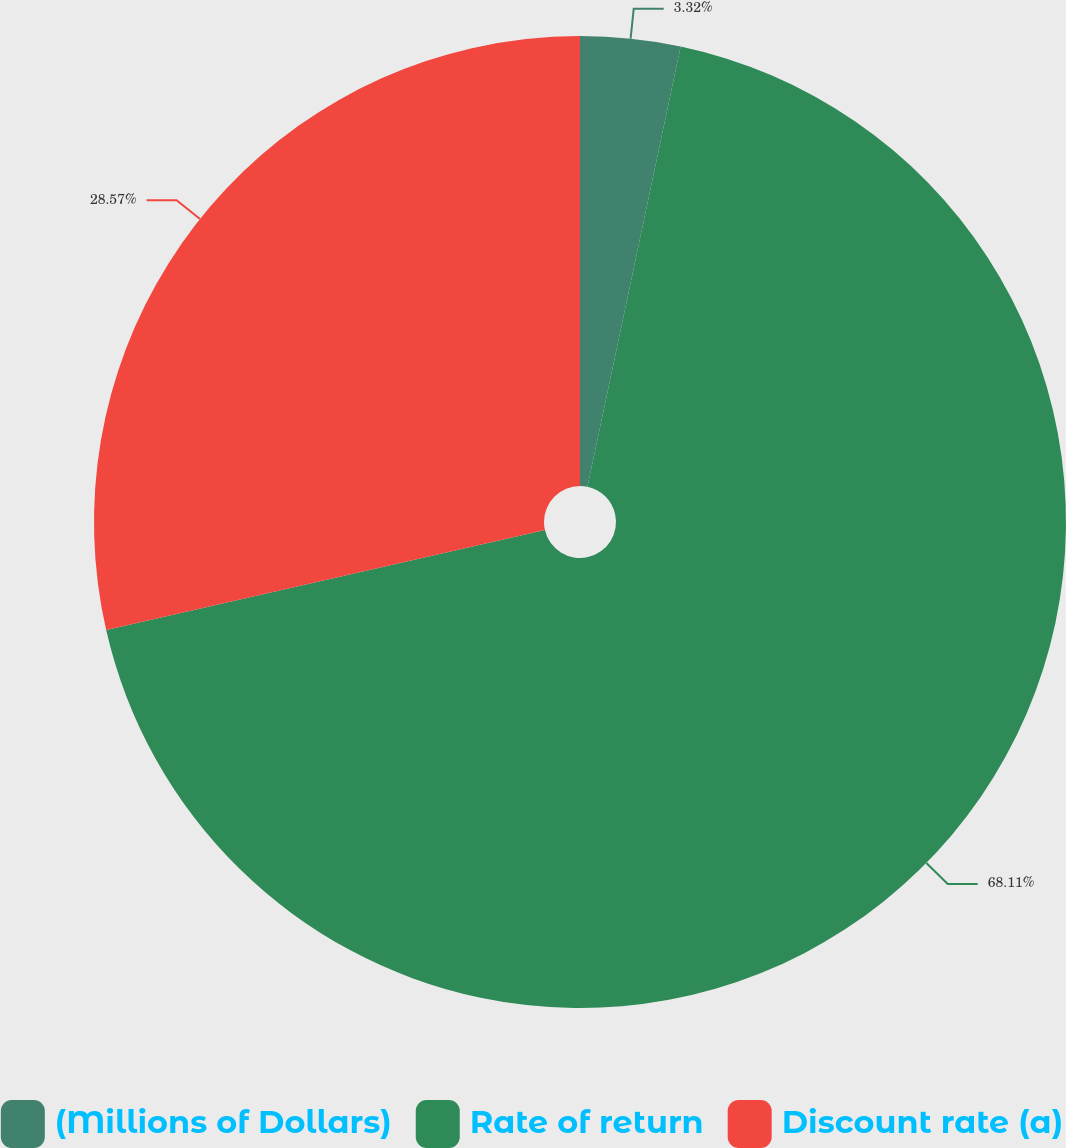Convert chart to OTSL. <chart><loc_0><loc_0><loc_500><loc_500><pie_chart><fcel>(Millions of Dollars)<fcel>Rate of return<fcel>Discount rate (a)<nl><fcel>3.32%<fcel>68.11%<fcel>28.57%<nl></chart> 